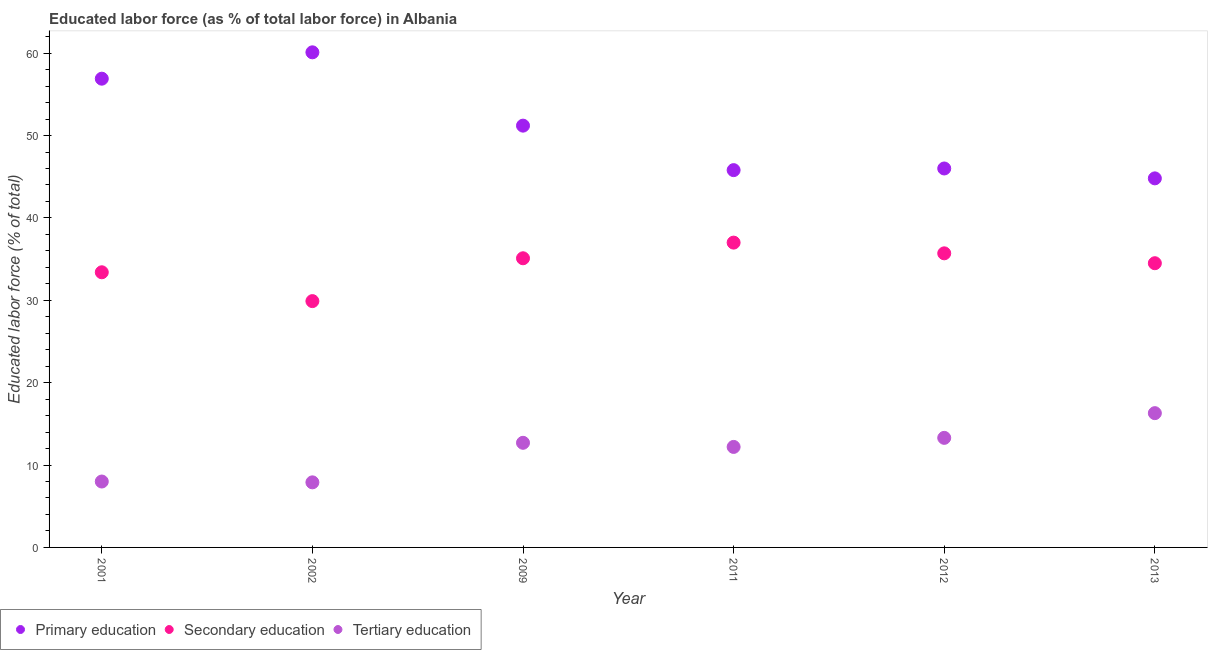How many different coloured dotlines are there?
Make the answer very short. 3. Is the number of dotlines equal to the number of legend labels?
Provide a short and direct response. Yes. What is the percentage of labor force who received secondary education in 2012?
Keep it short and to the point. 35.7. Across all years, what is the maximum percentage of labor force who received primary education?
Provide a short and direct response. 60.1. Across all years, what is the minimum percentage of labor force who received tertiary education?
Offer a very short reply. 7.9. In which year was the percentage of labor force who received tertiary education maximum?
Offer a very short reply. 2013. In which year was the percentage of labor force who received tertiary education minimum?
Ensure brevity in your answer.  2002. What is the total percentage of labor force who received primary education in the graph?
Provide a succinct answer. 304.8. What is the difference between the percentage of labor force who received secondary education in 2001 and that in 2011?
Provide a short and direct response. -3.6. What is the difference between the percentage of labor force who received tertiary education in 2011 and the percentage of labor force who received secondary education in 2009?
Make the answer very short. -22.9. What is the average percentage of labor force who received tertiary education per year?
Provide a short and direct response. 11.73. In the year 2012, what is the difference between the percentage of labor force who received tertiary education and percentage of labor force who received secondary education?
Offer a very short reply. -22.4. In how many years, is the percentage of labor force who received tertiary education greater than 60 %?
Your answer should be compact. 0. What is the ratio of the percentage of labor force who received secondary education in 2011 to that in 2013?
Your response must be concise. 1.07. What is the difference between the highest and the second highest percentage of labor force who received tertiary education?
Give a very brief answer. 3. What is the difference between the highest and the lowest percentage of labor force who received primary education?
Your response must be concise. 15.3. Is the percentage of labor force who received primary education strictly greater than the percentage of labor force who received tertiary education over the years?
Keep it short and to the point. Yes. Is the percentage of labor force who received tertiary education strictly less than the percentage of labor force who received primary education over the years?
Your answer should be compact. Yes. How many dotlines are there?
Offer a terse response. 3. How many legend labels are there?
Give a very brief answer. 3. What is the title of the graph?
Keep it short and to the point. Educated labor force (as % of total labor force) in Albania. Does "Industry" appear as one of the legend labels in the graph?
Your response must be concise. No. What is the label or title of the Y-axis?
Make the answer very short. Educated labor force (% of total). What is the Educated labor force (% of total) in Primary education in 2001?
Give a very brief answer. 56.9. What is the Educated labor force (% of total) of Secondary education in 2001?
Provide a succinct answer. 33.4. What is the Educated labor force (% of total) in Tertiary education in 2001?
Provide a short and direct response. 8. What is the Educated labor force (% of total) in Primary education in 2002?
Your answer should be very brief. 60.1. What is the Educated labor force (% of total) in Secondary education in 2002?
Ensure brevity in your answer.  29.9. What is the Educated labor force (% of total) in Tertiary education in 2002?
Offer a very short reply. 7.9. What is the Educated labor force (% of total) of Primary education in 2009?
Provide a short and direct response. 51.2. What is the Educated labor force (% of total) of Secondary education in 2009?
Make the answer very short. 35.1. What is the Educated labor force (% of total) of Tertiary education in 2009?
Your answer should be compact. 12.7. What is the Educated labor force (% of total) of Primary education in 2011?
Offer a terse response. 45.8. What is the Educated labor force (% of total) of Secondary education in 2011?
Give a very brief answer. 37. What is the Educated labor force (% of total) in Tertiary education in 2011?
Your response must be concise. 12.2. What is the Educated labor force (% of total) in Primary education in 2012?
Provide a short and direct response. 46. What is the Educated labor force (% of total) in Secondary education in 2012?
Your answer should be compact. 35.7. What is the Educated labor force (% of total) in Tertiary education in 2012?
Provide a succinct answer. 13.3. What is the Educated labor force (% of total) of Primary education in 2013?
Provide a short and direct response. 44.8. What is the Educated labor force (% of total) in Secondary education in 2013?
Offer a very short reply. 34.5. What is the Educated labor force (% of total) of Tertiary education in 2013?
Your response must be concise. 16.3. Across all years, what is the maximum Educated labor force (% of total) in Primary education?
Your response must be concise. 60.1. Across all years, what is the maximum Educated labor force (% of total) of Tertiary education?
Offer a terse response. 16.3. Across all years, what is the minimum Educated labor force (% of total) of Primary education?
Your answer should be compact. 44.8. Across all years, what is the minimum Educated labor force (% of total) in Secondary education?
Your answer should be very brief. 29.9. Across all years, what is the minimum Educated labor force (% of total) in Tertiary education?
Give a very brief answer. 7.9. What is the total Educated labor force (% of total) of Primary education in the graph?
Offer a terse response. 304.8. What is the total Educated labor force (% of total) of Secondary education in the graph?
Make the answer very short. 205.6. What is the total Educated labor force (% of total) in Tertiary education in the graph?
Offer a very short reply. 70.4. What is the difference between the Educated labor force (% of total) in Primary education in 2001 and that in 2002?
Ensure brevity in your answer.  -3.2. What is the difference between the Educated labor force (% of total) of Primary education in 2001 and that in 2009?
Your response must be concise. 5.7. What is the difference between the Educated labor force (% of total) of Primary education in 2001 and that in 2011?
Offer a very short reply. 11.1. What is the difference between the Educated labor force (% of total) of Tertiary education in 2001 and that in 2011?
Provide a succinct answer. -4.2. What is the difference between the Educated labor force (% of total) of Primary education in 2001 and that in 2012?
Your response must be concise. 10.9. What is the difference between the Educated labor force (% of total) in Tertiary education in 2001 and that in 2012?
Ensure brevity in your answer.  -5.3. What is the difference between the Educated labor force (% of total) in Primary education in 2001 and that in 2013?
Your answer should be compact. 12.1. What is the difference between the Educated labor force (% of total) of Tertiary education in 2001 and that in 2013?
Keep it short and to the point. -8.3. What is the difference between the Educated labor force (% of total) in Tertiary education in 2002 and that in 2009?
Offer a terse response. -4.8. What is the difference between the Educated labor force (% of total) in Primary education in 2002 and that in 2011?
Your answer should be very brief. 14.3. What is the difference between the Educated labor force (% of total) in Primary education in 2002 and that in 2012?
Make the answer very short. 14.1. What is the difference between the Educated labor force (% of total) in Secondary education in 2002 and that in 2012?
Ensure brevity in your answer.  -5.8. What is the difference between the Educated labor force (% of total) in Tertiary education in 2002 and that in 2012?
Provide a short and direct response. -5.4. What is the difference between the Educated labor force (% of total) in Tertiary education in 2002 and that in 2013?
Offer a very short reply. -8.4. What is the difference between the Educated labor force (% of total) in Primary education in 2009 and that in 2011?
Your response must be concise. 5.4. What is the difference between the Educated labor force (% of total) in Secondary education in 2009 and that in 2011?
Ensure brevity in your answer.  -1.9. What is the difference between the Educated labor force (% of total) of Tertiary education in 2009 and that in 2011?
Offer a terse response. 0.5. What is the difference between the Educated labor force (% of total) in Secondary education in 2009 and that in 2013?
Provide a succinct answer. 0.6. What is the difference between the Educated labor force (% of total) in Tertiary education in 2009 and that in 2013?
Ensure brevity in your answer.  -3.6. What is the difference between the Educated labor force (% of total) of Primary education in 2011 and that in 2013?
Make the answer very short. 1. What is the difference between the Educated labor force (% of total) in Primary education in 2012 and that in 2013?
Your answer should be very brief. 1.2. What is the difference between the Educated labor force (% of total) of Primary education in 2001 and the Educated labor force (% of total) of Secondary education in 2002?
Your answer should be compact. 27. What is the difference between the Educated labor force (% of total) of Primary education in 2001 and the Educated labor force (% of total) of Tertiary education in 2002?
Your answer should be very brief. 49. What is the difference between the Educated labor force (% of total) in Secondary education in 2001 and the Educated labor force (% of total) in Tertiary education in 2002?
Your answer should be compact. 25.5. What is the difference between the Educated labor force (% of total) in Primary education in 2001 and the Educated labor force (% of total) in Secondary education in 2009?
Give a very brief answer. 21.8. What is the difference between the Educated labor force (% of total) of Primary education in 2001 and the Educated labor force (% of total) of Tertiary education in 2009?
Keep it short and to the point. 44.2. What is the difference between the Educated labor force (% of total) of Secondary education in 2001 and the Educated labor force (% of total) of Tertiary education in 2009?
Provide a succinct answer. 20.7. What is the difference between the Educated labor force (% of total) of Primary education in 2001 and the Educated labor force (% of total) of Tertiary education in 2011?
Your answer should be very brief. 44.7. What is the difference between the Educated labor force (% of total) in Secondary education in 2001 and the Educated labor force (% of total) in Tertiary education in 2011?
Provide a succinct answer. 21.2. What is the difference between the Educated labor force (% of total) in Primary education in 2001 and the Educated labor force (% of total) in Secondary education in 2012?
Give a very brief answer. 21.2. What is the difference between the Educated labor force (% of total) in Primary education in 2001 and the Educated labor force (% of total) in Tertiary education in 2012?
Ensure brevity in your answer.  43.6. What is the difference between the Educated labor force (% of total) of Secondary education in 2001 and the Educated labor force (% of total) of Tertiary education in 2012?
Make the answer very short. 20.1. What is the difference between the Educated labor force (% of total) of Primary education in 2001 and the Educated labor force (% of total) of Secondary education in 2013?
Make the answer very short. 22.4. What is the difference between the Educated labor force (% of total) in Primary education in 2001 and the Educated labor force (% of total) in Tertiary education in 2013?
Keep it short and to the point. 40.6. What is the difference between the Educated labor force (% of total) of Secondary education in 2001 and the Educated labor force (% of total) of Tertiary education in 2013?
Offer a terse response. 17.1. What is the difference between the Educated labor force (% of total) in Primary education in 2002 and the Educated labor force (% of total) in Tertiary education in 2009?
Give a very brief answer. 47.4. What is the difference between the Educated labor force (% of total) of Primary education in 2002 and the Educated labor force (% of total) of Secondary education in 2011?
Your answer should be compact. 23.1. What is the difference between the Educated labor force (% of total) in Primary education in 2002 and the Educated labor force (% of total) in Tertiary education in 2011?
Ensure brevity in your answer.  47.9. What is the difference between the Educated labor force (% of total) of Primary education in 2002 and the Educated labor force (% of total) of Secondary education in 2012?
Give a very brief answer. 24.4. What is the difference between the Educated labor force (% of total) of Primary education in 2002 and the Educated labor force (% of total) of Tertiary education in 2012?
Provide a short and direct response. 46.8. What is the difference between the Educated labor force (% of total) in Secondary education in 2002 and the Educated labor force (% of total) in Tertiary education in 2012?
Offer a terse response. 16.6. What is the difference between the Educated labor force (% of total) of Primary education in 2002 and the Educated labor force (% of total) of Secondary education in 2013?
Ensure brevity in your answer.  25.6. What is the difference between the Educated labor force (% of total) in Primary education in 2002 and the Educated labor force (% of total) in Tertiary education in 2013?
Give a very brief answer. 43.8. What is the difference between the Educated labor force (% of total) of Secondary education in 2002 and the Educated labor force (% of total) of Tertiary education in 2013?
Ensure brevity in your answer.  13.6. What is the difference between the Educated labor force (% of total) in Primary education in 2009 and the Educated labor force (% of total) in Tertiary education in 2011?
Your answer should be very brief. 39. What is the difference between the Educated labor force (% of total) in Secondary education in 2009 and the Educated labor force (% of total) in Tertiary education in 2011?
Keep it short and to the point. 22.9. What is the difference between the Educated labor force (% of total) of Primary education in 2009 and the Educated labor force (% of total) of Tertiary education in 2012?
Provide a short and direct response. 37.9. What is the difference between the Educated labor force (% of total) of Secondary education in 2009 and the Educated labor force (% of total) of Tertiary education in 2012?
Keep it short and to the point. 21.8. What is the difference between the Educated labor force (% of total) of Primary education in 2009 and the Educated labor force (% of total) of Secondary education in 2013?
Offer a very short reply. 16.7. What is the difference between the Educated labor force (% of total) in Primary education in 2009 and the Educated labor force (% of total) in Tertiary education in 2013?
Your answer should be very brief. 34.9. What is the difference between the Educated labor force (% of total) in Secondary education in 2009 and the Educated labor force (% of total) in Tertiary education in 2013?
Provide a succinct answer. 18.8. What is the difference between the Educated labor force (% of total) of Primary education in 2011 and the Educated labor force (% of total) of Secondary education in 2012?
Your response must be concise. 10.1. What is the difference between the Educated labor force (% of total) in Primary education in 2011 and the Educated labor force (% of total) in Tertiary education in 2012?
Keep it short and to the point. 32.5. What is the difference between the Educated labor force (% of total) of Secondary education in 2011 and the Educated labor force (% of total) of Tertiary education in 2012?
Offer a terse response. 23.7. What is the difference between the Educated labor force (% of total) of Primary education in 2011 and the Educated labor force (% of total) of Tertiary education in 2013?
Your response must be concise. 29.5. What is the difference between the Educated labor force (% of total) in Secondary education in 2011 and the Educated labor force (% of total) in Tertiary education in 2013?
Your response must be concise. 20.7. What is the difference between the Educated labor force (% of total) in Primary education in 2012 and the Educated labor force (% of total) in Secondary education in 2013?
Keep it short and to the point. 11.5. What is the difference between the Educated labor force (% of total) of Primary education in 2012 and the Educated labor force (% of total) of Tertiary education in 2013?
Ensure brevity in your answer.  29.7. What is the average Educated labor force (% of total) of Primary education per year?
Offer a very short reply. 50.8. What is the average Educated labor force (% of total) of Secondary education per year?
Give a very brief answer. 34.27. What is the average Educated labor force (% of total) of Tertiary education per year?
Provide a short and direct response. 11.73. In the year 2001, what is the difference between the Educated labor force (% of total) in Primary education and Educated labor force (% of total) in Secondary education?
Provide a short and direct response. 23.5. In the year 2001, what is the difference between the Educated labor force (% of total) of Primary education and Educated labor force (% of total) of Tertiary education?
Provide a succinct answer. 48.9. In the year 2001, what is the difference between the Educated labor force (% of total) of Secondary education and Educated labor force (% of total) of Tertiary education?
Provide a succinct answer. 25.4. In the year 2002, what is the difference between the Educated labor force (% of total) of Primary education and Educated labor force (% of total) of Secondary education?
Offer a terse response. 30.2. In the year 2002, what is the difference between the Educated labor force (% of total) in Primary education and Educated labor force (% of total) in Tertiary education?
Give a very brief answer. 52.2. In the year 2002, what is the difference between the Educated labor force (% of total) of Secondary education and Educated labor force (% of total) of Tertiary education?
Make the answer very short. 22. In the year 2009, what is the difference between the Educated labor force (% of total) of Primary education and Educated labor force (% of total) of Secondary education?
Ensure brevity in your answer.  16.1. In the year 2009, what is the difference between the Educated labor force (% of total) of Primary education and Educated labor force (% of total) of Tertiary education?
Your answer should be compact. 38.5. In the year 2009, what is the difference between the Educated labor force (% of total) of Secondary education and Educated labor force (% of total) of Tertiary education?
Give a very brief answer. 22.4. In the year 2011, what is the difference between the Educated labor force (% of total) of Primary education and Educated labor force (% of total) of Secondary education?
Offer a very short reply. 8.8. In the year 2011, what is the difference between the Educated labor force (% of total) in Primary education and Educated labor force (% of total) in Tertiary education?
Give a very brief answer. 33.6. In the year 2011, what is the difference between the Educated labor force (% of total) of Secondary education and Educated labor force (% of total) of Tertiary education?
Your answer should be compact. 24.8. In the year 2012, what is the difference between the Educated labor force (% of total) in Primary education and Educated labor force (% of total) in Tertiary education?
Offer a very short reply. 32.7. In the year 2012, what is the difference between the Educated labor force (% of total) in Secondary education and Educated labor force (% of total) in Tertiary education?
Offer a very short reply. 22.4. In the year 2013, what is the difference between the Educated labor force (% of total) of Primary education and Educated labor force (% of total) of Tertiary education?
Provide a succinct answer. 28.5. In the year 2013, what is the difference between the Educated labor force (% of total) of Secondary education and Educated labor force (% of total) of Tertiary education?
Give a very brief answer. 18.2. What is the ratio of the Educated labor force (% of total) of Primary education in 2001 to that in 2002?
Offer a very short reply. 0.95. What is the ratio of the Educated labor force (% of total) in Secondary education in 2001 to that in 2002?
Keep it short and to the point. 1.12. What is the ratio of the Educated labor force (% of total) in Tertiary education in 2001 to that in 2002?
Your answer should be compact. 1.01. What is the ratio of the Educated labor force (% of total) of Primary education in 2001 to that in 2009?
Provide a short and direct response. 1.11. What is the ratio of the Educated labor force (% of total) in Secondary education in 2001 to that in 2009?
Offer a very short reply. 0.95. What is the ratio of the Educated labor force (% of total) of Tertiary education in 2001 to that in 2009?
Offer a terse response. 0.63. What is the ratio of the Educated labor force (% of total) of Primary education in 2001 to that in 2011?
Offer a very short reply. 1.24. What is the ratio of the Educated labor force (% of total) in Secondary education in 2001 to that in 2011?
Provide a succinct answer. 0.9. What is the ratio of the Educated labor force (% of total) in Tertiary education in 2001 to that in 2011?
Offer a very short reply. 0.66. What is the ratio of the Educated labor force (% of total) of Primary education in 2001 to that in 2012?
Provide a succinct answer. 1.24. What is the ratio of the Educated labor force (% of total) of Secondary education in 2001 to that in 2012?
Provide a succinct answer. 0.94. What is the ratio of the Educated labor force (% of total) of Tertiary education in 2001 to that in 2012?
Make the answer very short. 0.6. What is the ratio of the Educated labor force (% of total) of Primary education in 2001 to that in 2013?
Provide a short and direct response. 1.27. What is the ratio of the Educated labor force (% of total) of Secondary education in 2001 to that in 2013?
Your answer should be compact. 0.97. What is the ratio of the Educated labor force (% of total) of Tertiary education in 2001 to that in 2013?
Offer a very short reply. 0.49. What is the ratio of the Educated labor force (% of total) of Primary education in 2002 to that in 2009?
Your response must be concise. 1.17. What is the ratio of the Educated labor force (% of total) in Secondary education in 2002 to that in 2009?
Offer a terse response. 0.85. What is the ratio of the Educated labor force (% of total) of Tertiary education in 2002 to that in 2009?
Keep it short and to the point. 0.62. What is the ratio of the Educated labor force (% of total) of Primary education in 2002 to that in 2011?
Your answer should be compact. 1.31. What is the ratio of the Educated labor force (% of total) in Secondary education in 2002 to that in 2011?
Your answer should be very brief. 0.81. What is the ratio of the Educated labor force (% of total) in Tertiary education in 2002 to that in 2011?
Provide a succinct answer. 0.65. What is the ratio of the Educated labor force (% of total) of Primary education in 2002 to that in 2012?
Your answer should be compact. 1.31. What is the ratio of the Educated labor force (% of total) in Secondary education in 2002 to that in 2012?
Provide a short and direct response. 0.84. What is the ratio of the Educated labor force (% of total) in Tertiary education in 2002 to that in 2012?
Offer a terse response. 0.59. What is the ratio of the Educated labor force (% of total) of Primary education in 2002 to that in 2013?
Provide a short and direct response. 1.34. What is the ratio of the Educated labor force (% of total) in Secondary education in 2002 to that in 2013?
Your answer should be very brief. 0.87. What is the ratio of the Educated labor force (% of total) in Tertiary education in 2002 to that in 2013?
Give a very brief answer. 0.48. What is the ratio of the Educated labor force (% of total) in Primary education in 2009 to that in 2011?
Keep it short and to the point. 1.12. What is the ratio of the Educated labor force (% of total) in Secondary education in 2009 to that in 2011?
Keep it short and to the point. 0.95. What is the ratio of the Educated labor force (% of total) of Tertiary education in 2009 to that in 2011?
Keep it short and to the point. 1.04. What is the ratio of the Educated labor force (% of total) of Primary education in 2009 to that in 2012?
Your answer should be compact. 1.11. What is the ratio of the Educated labor force (% of total) in Secondary education in 2009 to that in 2012?
Provide a succinct answer. 0.98. What is the ratio of the Educated labor force (% of total) of Tertiary education in 2009 to that in 2012?
Your answer should be very brief. 0.95. What is the ratio of the Educated labor force (% of total) in Primary education in 2009 to that in 2013?
Keep it short and to the point. 1.14. What is the ratio of the Educated labor force (% of total) in Secondary education in 2009 to that in 2013?
Keep it short and to the point. 1.02. What is the ratio of the Educated labor force (% of total) of Tertiary education in 2009 to that in 2013?
Your response must be concise. 0.78. What is the ratio of the Educated labor force (% of total) of Primary education in 2011 to that in 2012?
Your response must be concise. 1. What is the ratio of the Educated labor force (% of total) in Secondary education in 2011 to that in 2012?
Make the answer very short. 1.04. What is the ratio of the Educated labor force (% of total) of Tertiary education in 2011 to that in 2012?
Make the answer very short. 0.92. What is the ratio of the Educated labor force (% of total) of Primary education in 2011 to that in 2013?
Offer a terse response. 1.02. What is the ratio of the Educated labor force (% of total) of Secondary education in 2011 to that in 2013?
Your answer should be very brief. 1.07. What is the ratio of the Educated labor force (% of total) of Tertiary education in 2011 to that in 2013?
Your response must be concise. 0.75. What is the ratio of the Educated labor force (% of total) of Primary education in 2012 to that in 2013?
Your answer should be compact. 1.03. What is the ratio of the Educated labor force (% of total) in Secondary education in 2012 to that in 2013?
Make the answer very short. 1.03. What is the ratio of the Educated labor force (% of total) in Tertiary education in 2012 to that in 2013?
Your answer should be very brief. 0.82. What is the difference between the highest and the second highest Educated labor force (% of total) of Secondary education?
Provide a short and direct response. 1.3. What is the difference between the highest and the second highest Educated labor force (% of total) in Tertiary education?
Provide a succinct answer. 3. What is the difference between the highest and the lowest Educated labor force (% of total) in Secondary education?
Provide a short and direct response. 7.1. What is the difference between the highest and the lowest Educated labor force (% of total) of Tertiary education?
Offer a very short reply. 8.4. 